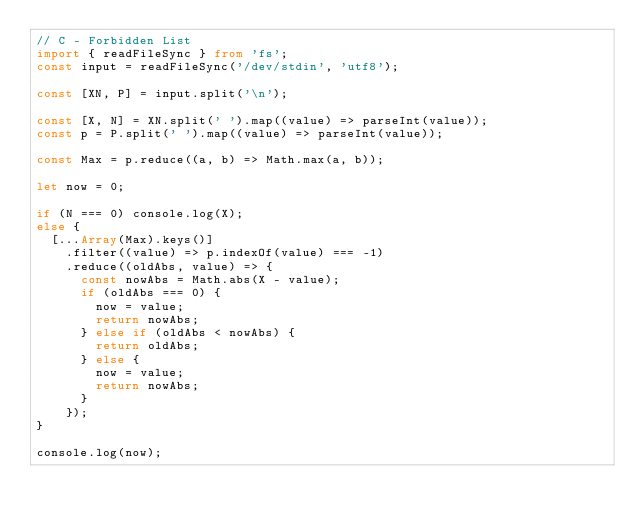Convert code to text. <code><loc_0><loc_0><loc_500><loc_500><_TypeScript_>// C - Forbidden List
import { readFileSync } from 'fs';
const input = readFileSync('/dev/stdin', 'utf8');

const [XN, P] = input.split('\n');

const [X, N] = XN.split(' ').map((value) => parseInt(value));
const p = P.split(' ').map((value) => parseInt(value));

const Max = p.reduce((a, b) => Math.max(a, b));

let now = 0;

if (N === 0) console.log(X);
else {
  [...Array(Max).keys()]
    .filter((value) => p.indexOf(value) === -1)
    .reduce((oldAbs, value) => {
      const nowAbs = Math.abs(X - value);
      if (oldAbs === 0) {
        now = value;
        return nowAbs;
      } else if (oldAbs < nowAbs) {
        return oldAbs;
      } else {
        now = value;
        return nowAbs;
      }
    });
}

console.log(now);
</code> 